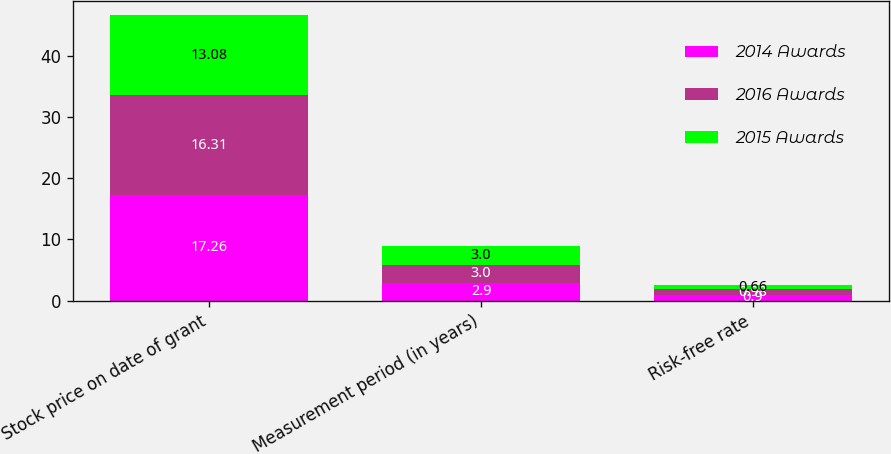Convert chart to OTSL. <chart><loc_0><loc_0><loc_500><loc_500><stacked_bar_chart><ecel><fcel>Stock price on date of grant<fcel>Measurement period (in years)<fcel>Risk-free rate<nl><fcel>2014 Awards<fcel>17.26<fcel>2.9<fcel>0.9<nl><fcel>2016 Awards<fcel>16.31<fcel>3<fcel>0.98<nl><fcel>2015 Awards<fcel>13.08<fcel>3<fcel>0.66<nl></chart> 